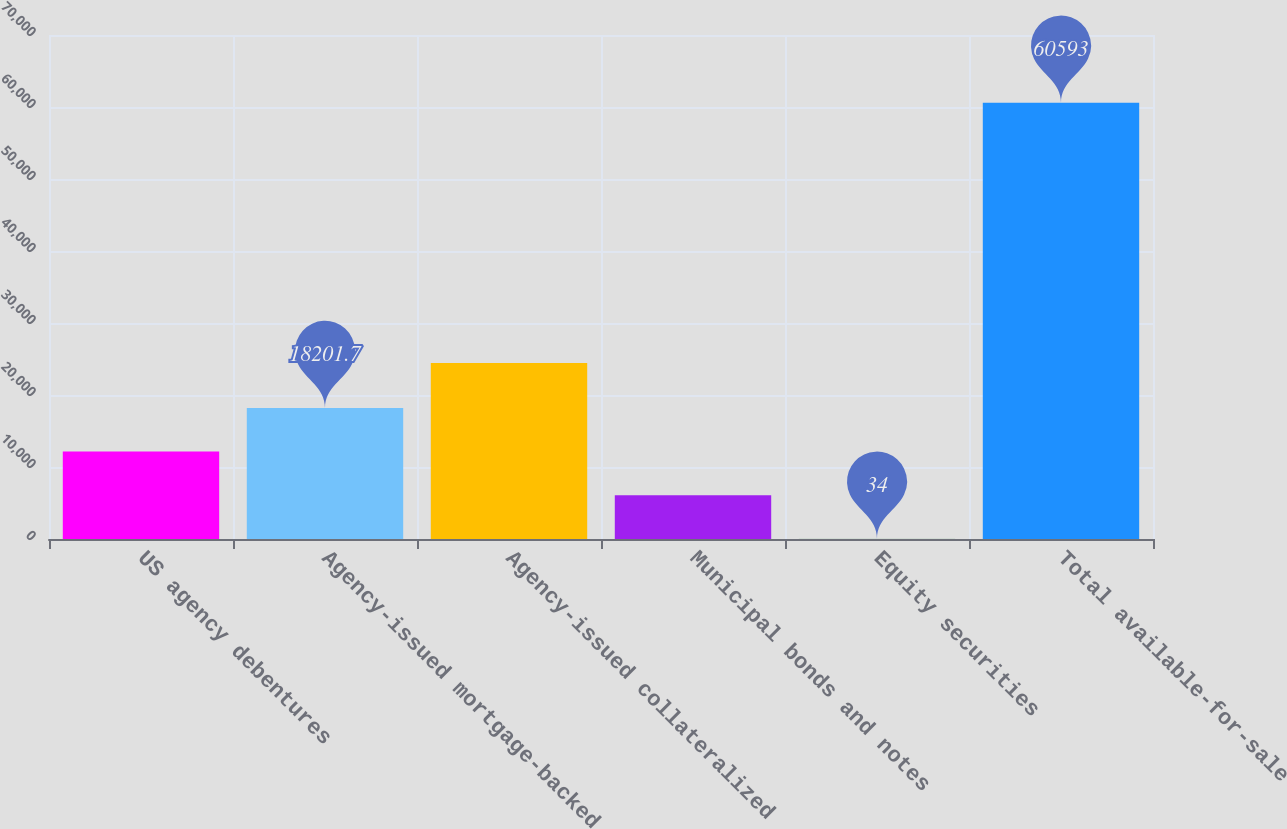Convert chart to OTSL. <chart><loc_0><loc_0><loc_500><loc_500><bar_chart><fcel>US agency debentures<fcel>Agency-issued mortgage-backed<fcel>Agency-issued collateralized<fcel>Municipal bonds and notes<fcel>Equity securities<fcel>Total available-for-sale<nl><fcel>12145.8<fcel>18201.7<fcel>24435<fcel>6089.9<fcel>34<fcel>60593<nl></chart> 